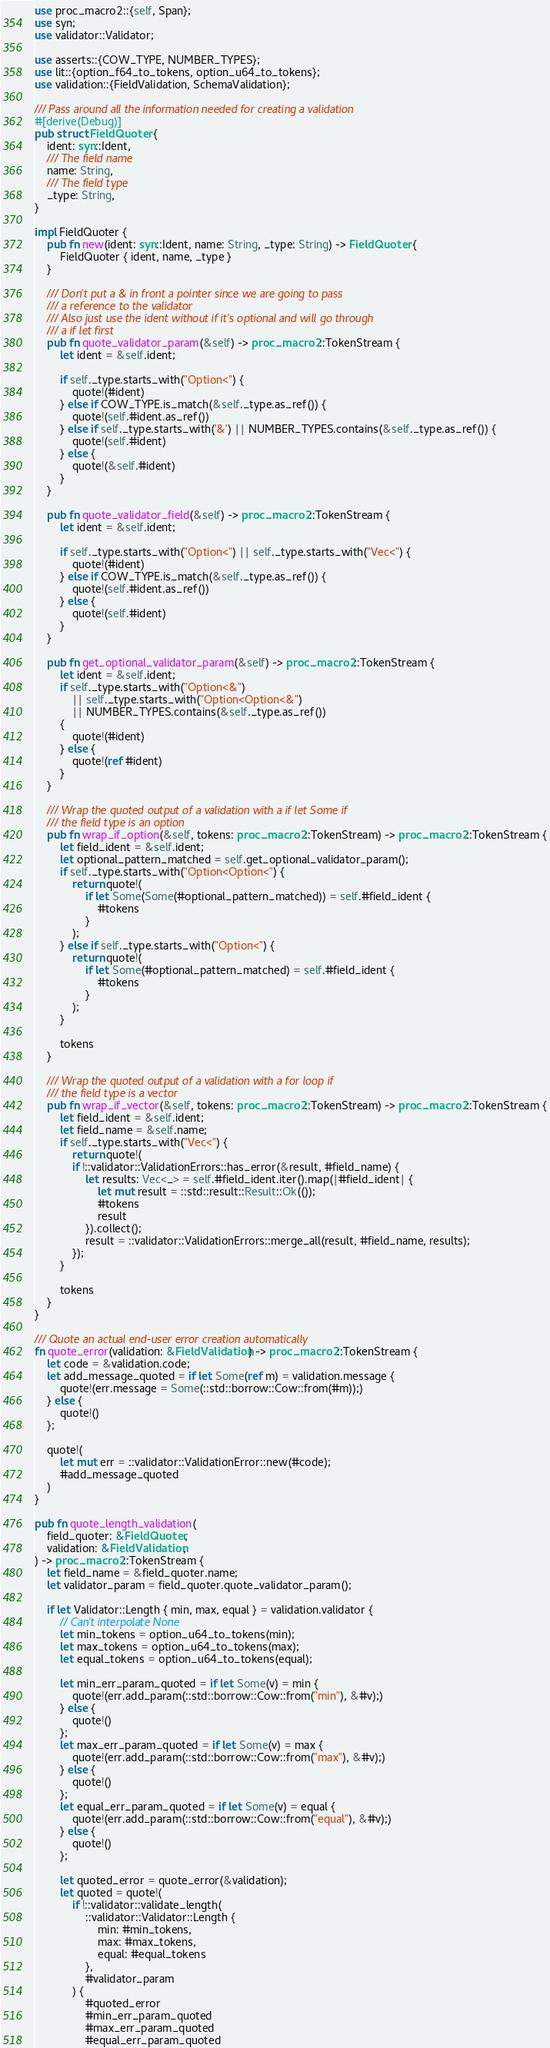Convert code to text. <code><loc_0><loc_0><loc_500><loc_500><_Rust_>use proc_macro2::{self, Span};
use syn;
use validator::Validator;

use asserts::{COW_TYPE, NUMBER_TYPES};
use lit::{option_f64_to_tokens, option_u64_to_tokens};
use validation::{FieldValidation, SchemaValidation};

/// Pass around all the information needed for creating a validation
#[derive(Debug)]
pub struct FieldQuoter {
    ident: syn::Ident,
    /// The field name
    name: String,
    /// The field type
    _type: String,
}

impl FieldQuoter {
    pub fn new(ident: syn::Ident, name: String, _type: String) -> FieldQuoter {
        FieldQuoter { ident, name, _type }
    }

    /// Don't put a & in front a pointer since we are going to pass
    /// a reference to the validator
    /// Also just use the ident without if it's optional and will go through
    /// a if let first
    pub fn quote_validator_param(&self) -> proc_macro2::TokenStream {
        let ident = &self.ident;

        if self._type.starts_with("Option<") {
            quote!(#ident)
        } else if COW_TYPE.is_match(&self._type.as_ref()) {
            quote!(self.#ident.as_ref())
        } else if self._type.starts_with('&') || NUMBER_TYPES.contains(&self._type.as_ref()) {
            quote!(self.#ident)
        } else {
            quote!(&self.#ident)
        }
    }

    pub fn quote_validator_field(&self) -> proc_macro2::TokenStream {
        let ident = &self.ident;

        if self._type.starts_with("Option<") || self._type.starts_with("Vec<") {
            quote!(#ident)
        } else if COW_TYPE.is_match(&self._type.as_ref()) {
            quote!(self.#ident.as_ref())
        } else {
            quote!(self.#ident)
        }
    }

    pub fn get_optional_validator_param(&self) -> proc_macro2::TokenStream {
        let ident = &self.ident;
        if self._type.starts_with("Option<&")
            || self._type.starts_with("Option<Option<&")
            || NUMBER_TYPES.contains(&self._type.as_ref())
        {
            quote!(#ident)
        } else {
            quote!(ref #ident)
        }
    }

    /// Wrap the quoted output of a validation with a if let Some if
    /// the field type is an option
    pub fn wrap_if_option(&self, tokens: proc_macro2::TokenStream) -> proc_macro2::TokenStream {
        let field_ident = &self.ident;
        let optional_pattern_matched = self.get_optional_validator_param();
        if self._type.starts_with("Option<Option<") {
            return quote!(
                if let Some(Some(#optional_pattern_matched)) = self.#field_ident {
                    #tokens
                }
            );
        } else if self._type.starts_with("Option<") {
            return quote!(
                if let Some(#optional_pattern_matched) = self.#field_ident {
                    #tokens
                }
            );
        }

        tokens
    }

    /// Wrap the quoted output of a validation with a for loop if
    /// the field type is a vector
    pub fn wrap_if_vector(&self, tokens: proc_macro2::TokenStream) -> proc_macro2::TokenStream {
        let field_ident = &self.ident;
        let field_name = &self.name;
        if self._type.starts_with("Vec<") {
            return quote!(
            if !::validator::ValidationErrors::has_error(&result, #field_name) {
                let results: Vec<_> = self.#field_ident.iter().map(|#field_ident| {
                    let mut result = ::std::result::Result::Ok(());
                    #tokens
                    result
                }).collect();
                result = ::validator::ValidationErrors::merge_all(result, #field_name, results);
            });
        }

        tokens
    }
}

/// Quote an actual end-user error creation automatically
fn quote_error(validation: &FieldValidation) -> proc_macro2::TokenStream {
    let code = &validation.code;
    let add_message_quoted = if let Some(ref m) = validation.message {
        quote!(err.message = Some(::std::borrow::Cow::from(#m));)
    } else {
        quote!()
    };

    quote!(
        let mut err = ::validator::ValidationError::new(#code);
        #add_message_quoted
    )
}

pub fn quote_length_validation(
    field_quoter: &FieldQuoter,
    validation: &FieldValidation,
) -> proc_macro2::TokenStream {
    let field_name = &field_quoter.name;
    let validator_param = field_quoter.quote_validator_param();

    if let Validator::Length { min, max, equal } = validation.validator {
        // Can't interpolate None
        let min_tokens = option_u64_to_tokens(min);
        let max_tokens = option_u64_to_tokens(max);
        let equal_tokens = option_u64_to_tokens(equal);

        let min_err_param_quoted = if let Some(v) = min {
            quote!(err.add_param(::std::borrow::Cow::from("min"), &#v);)
        } else {
            quote!()
        };
        let max_err_param_quoted = if let Some(v) = max {
            quote!(err.add_param(::std::borrow::Cow::from("max"), &#v);)
        } else {
            quote!()
        };
        let equal_err_param_quoted = if let Some(v) = equal {
            quote!(err.add_param(::std::borrow::Cow::from("equal"), &#v);)
        } else {
            quote!()
        };

        let quoted_error = quote_error(&validation);
        let quoted = quote!(
            if !::validator::validate_length(
                ::validator::Validator::Length {
                    min: #min_tokens,
                    max: #max_tokens,
                    equal: #equal_tokens
                },
                #validator_param
            ) {
                #quoted_error
                #min_err_param_quoted
                #max_err_param_quoted
                #equal_err_param_quoted</code> 